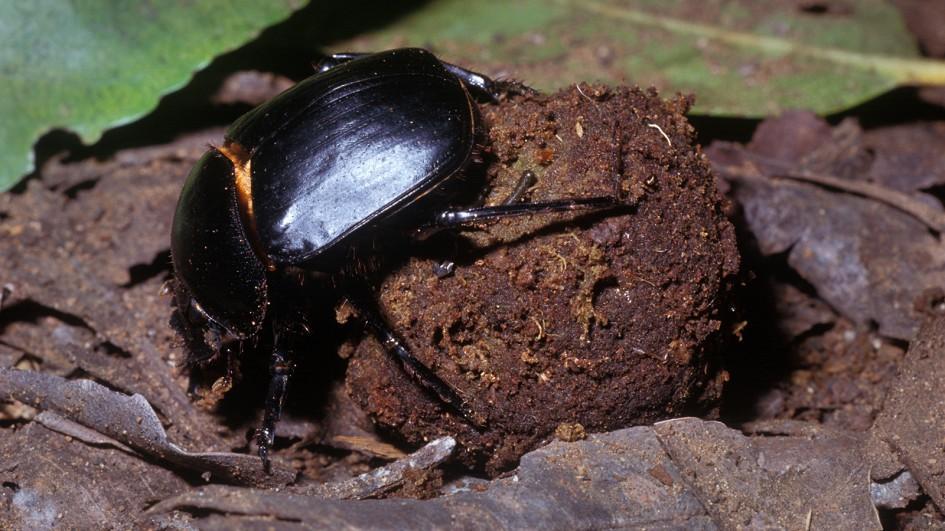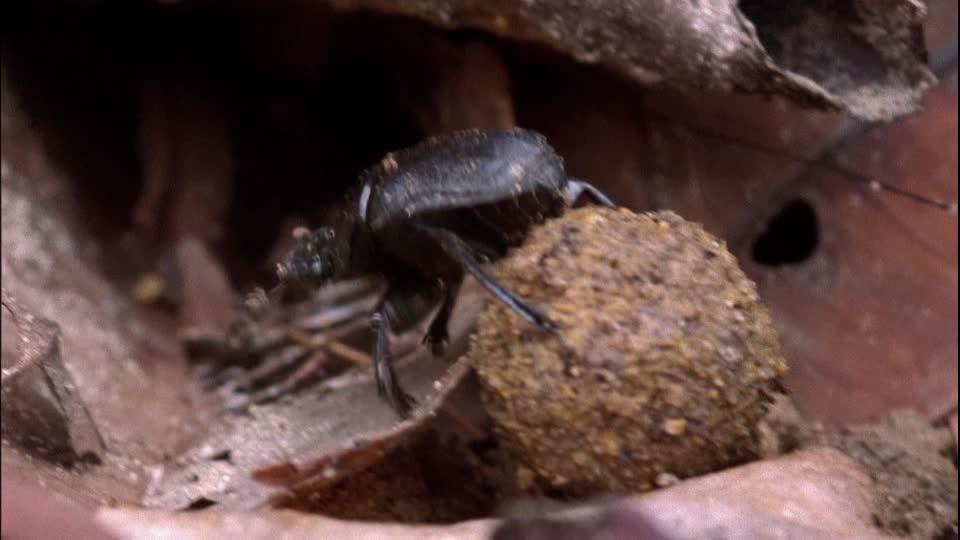The first image is the image on the left, the second image is the image on the right. Considering the images on both sides, is "The ball in one of the images is not brown." valid? Answer yes or no. No. The first image is the image on the left, the second image is the image on the right. Given the left and right images, does the statement "The insect in the image on the right is standing on top of the ball." hold true? Answer yes or no. Yes. The first image is the image on the left, the second image is the image on the right. Given the left and right images, does the statement "An image shows two beetles in proximity to a blue ball." hold true? Answer yes or no. No. 